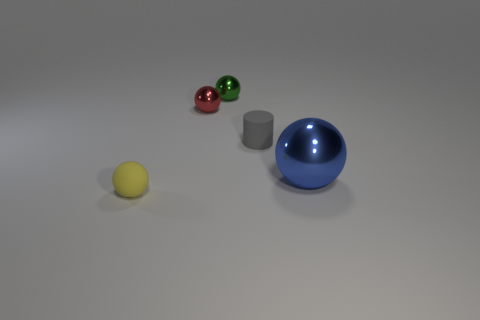Subtract all small spheres. How many spheres are left? 1 Add 2 tiny red balls. How many objects exist? 7 Subtract all red balls. How many balls are left? 3 Subtract all cylinders. How many objects are left? 4 Subtract 2 balls. How many balls are left? 2 Subtract all brown cylinders. How many blue balls are left? 1 Subtract all balls. Subtract all big things. How many objects are left? 0 Add 2 matte balls. How many matte balls are left? 3 Add 1 small balls. How many small balls exist? 4 Subtract 0 purple balls. How many objects are left? 5 